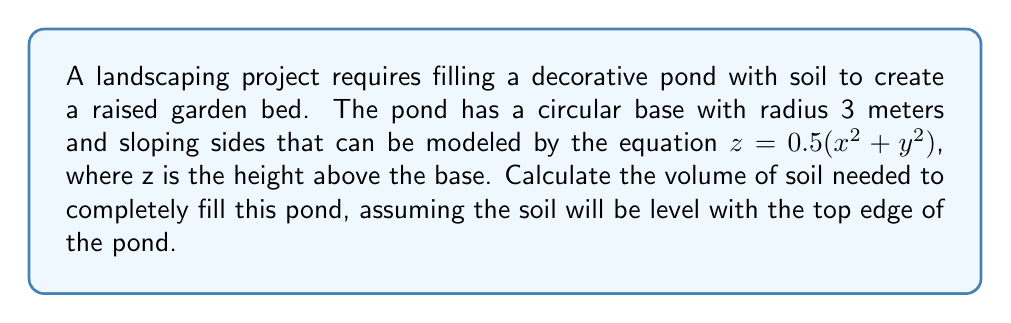Help me with this question. To solve this problem, we'll use multivariable calculus, specifically triple integrals in cylindrical coordinates.

Step 1: Identify the limits of integration
- Radial limit: $0 \leq r \leq 3$
- Angular limit: $0 \leq \theta \leq 2\pi$
- Height limit: $0 \leq z \leq 0.5(x^2 + y^2)$

Step 2: Set up the triple integral
$$V = \int_0^{2\pi} \int_0^3 \int_0^{0.5r^2} r \, dz \, dr \, d\theta$$

Step 3: Solve the innermost integral (with respect to z)
$$V = \int_0^{2\pi} \int_0^3 [rz]_0^{0.5r^2} \, dr \, d\theta = \int_0^{2\pi} \int_0^3 0.5r^3 \, dr \, d\theta$$

Step 4: Solve the integral with respect to r
$$V = \int_0^{2\pi} \left[\frac{0.5r^4}{4}\right]_0^3 \, d\theta = \int_0^{2\pi} \frac{81}{8} \, d\theta$$

Step 5: Solve the final integral with respect to θ
$$V = \left[\frac{81}{8}\theta\right]_0^{2\pi} = \frac{81}{8} \cdot 2\pi = \frac{81\pi}{4}$$

Therefore, the volume of soil needed is $\frac{81\pi}{4}$ cubic meters.
Answer: $\frac{81\pi}{4}$ m³ 